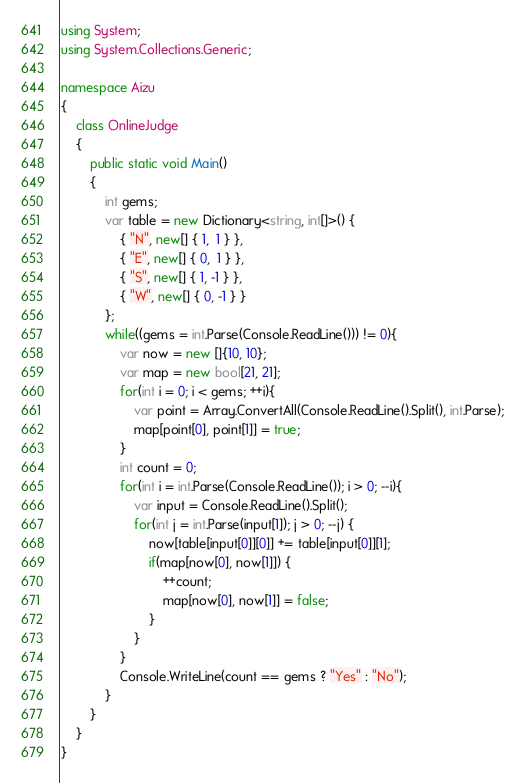<code> <loc_0><loc_0><loc_500><loc_500><_C#_>using System;
using System.Collections.Generic;
 
namespace Aizu
{
    class OnlineJudge
    {
        public static void Main()
        {
            int gems;
            var table = new Dictionary<string, int[]>() {
                { "N", new[] { 1,  1 } },
                { "E", new[] { 0,  1 } },
                { "S", new[] { 1, -1 } },
                { "W", new[] { 0, -1 } }
            };
            while((gems = int.Parse(Console.ReadLine())) != 0){
                var now = new []{10, 10};
                var map = new bool[21, 21];
                for(int i = 0; i < gems; ++i){
                    var point = Array.ConvertAll(Console.ReadLine().Split(), int.Parse);
                    map[point[0], point[1]] = true;
                }
                int count = 0;
                for(int i = int.Parse(Console.ReadLine()); i > 0; --i){
                    var input = Console.ReadLine().Split();
                    for(int j = int.Parse(input[1]); j > 0; --j) {
                        now[table[input[0]][0]] += table[input[0]][1];
                        if(map[now[0], now[1]]) {
                            ++count;
                            map[now[0], now[1]] = false;
                        }
                    }
                }
                Console.WriteLine(count == gems ? "Yes" : "No");
            }
        }
    }
}</code> 